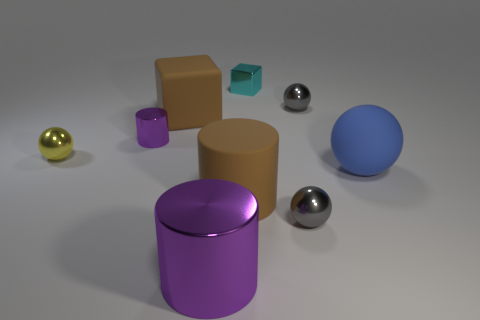Subtract all brown rubber cylinders. How many cylinders are left? 2 Subtract all gray spheres. How many spheres are left? 2 Add 1 purple shiny cylinders. How many objects exist? 10 Subtract 2 balls. How many balls are left? 2 Subtract all cubes. How many objects are left? 7 Subtract all metal spheres. Subtract all rubber objects. How many objects are left? 3 Add 9 yellow metallic balls. How many yellow metallic balls are left? 10 Add 1 large cylinders. How many large cylinders exist? 3 Subtract 1 gray balls. How many objects are left? 8 Subtract all yellow blocks. Subtract all green cylinders. How many blocks are left? 2 